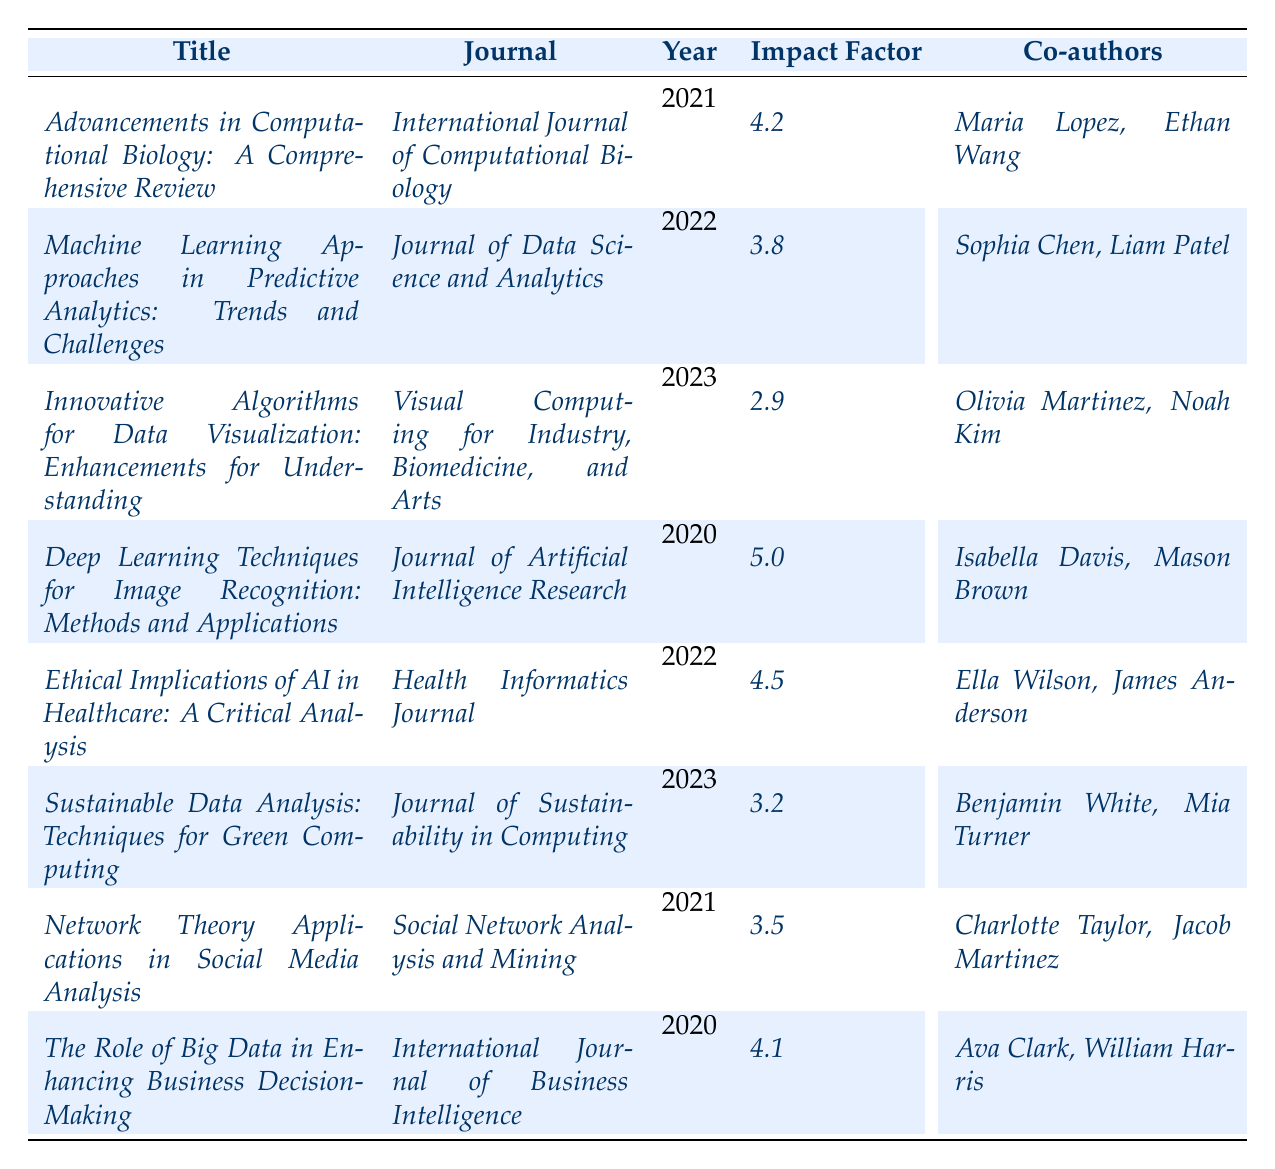What is the title of the paper published in 2023? In the table, we look for the entry with the year 2023, which is the paper titled "Innovative Algorithms for Data Visualization: Enhancements for Understanding."
Answer: Innovative Algorithms for Data Visualization: Enhancements for Understanding Which journal features Francesc Bonet's paper on ethical implications in AI? By scanning the corresponding row for the title "_Ethical Implications of AI in Healthcare: A Critical Analysis_," we find it is published in the "Health Informatics Journal."
Answer: Health Informatics Journal How many co-authors are listed for the paper published in 2021? Looking at the entry for 2021, "_Advancements in Computational Biology: A Comprehensive Review_," it lists two co-authors: "Maria Lopez" and "Ethan Wang."
Answer: 2 What is the impact factor of the paper on machine learning from 2022? The entry for 2022, "_Machine Learning Approaches in Predictive Analytics: Trends and Challenges_," shows an impact factor of 3.8 directly in the table.
Answer: 3.8 Is the impact factor of the paper titled "_Deep Learning Techniques for Image Recognition_" greater than 4? The table indicates that this paper has an impact factor of 5.0, which is indeed greater than 4.
Answer: Yes Which year had the highest impact factor recorded in the table? We compare all impact factors listed: 4.2 (2021), 3.8 (2022), 2.9 (2023), 5.0 (2020), 4.5 (2022), 3.2 (2023), 3.5 (2021), and 4.1 (2020). The highest is 5.0 in 2020.
Answer: 2020 How many papers authored by Francesc Bonet were published in 2023? We check the entries for 2023 and find two papers: "_Innovative Algorithms for Data Visualization: Enhancements for Understanding_" and "_Sustainable Data Analysis: Techniques for Green Computing_."
Answer: 2 What is the average impact factor of all the papers written by Francesc Bonet? We sum the impact factors: 4.2 + 3.8 + 2.9 + 5.0 + 4.5 + 3.2 + 3.5 + 4.1 = 31.2. There are 8 papers, so the average is 31.2/8 = 3.90.
Answer: 3.90 In which journal did Francesc Bonet publish more than one paper? Checking the table reveals that the "International Journal of Business Intelligence" and "Health Informatics Journal" themes both have singular papers, while the "International Journal of Computational Biology" and "Social Network Analysis and Mining" only have one each, thus the answer is no journals have more than one paper.
Answer: No Which paper has the lowest impact factor, and what is that value? Reviewing the impact factors, we see "_Innovative Algorithms for Data Visualization: Enhancements for Understanding_" has the lowest at 2.9.
Answer: 2.9 